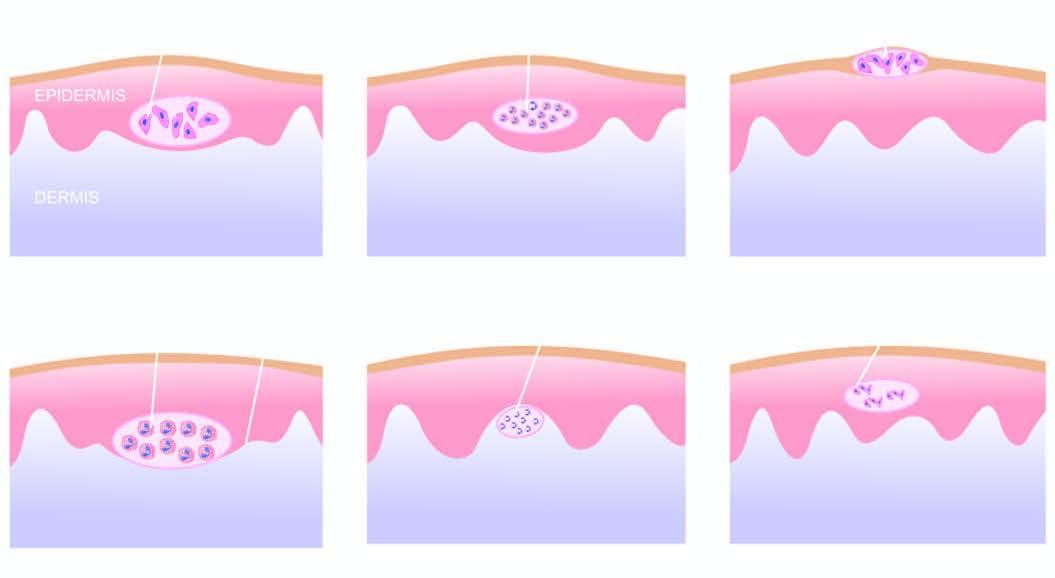does individual myocardial fibres show necrotic keratinocytes and inflammatory cells?
Answer the question using a single word or phrase. No 